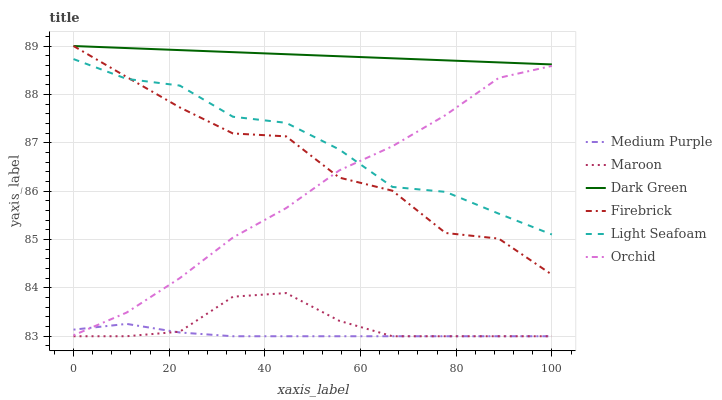Does Medium Purple have the minimum area under the curve?
Answer yes or no. Yes. Does Dark Green have the maximum area under the curve?
Answer yes or no. Yes. Does Maroon have the minimum area under the curve?
Answer yes or no. No. Does Maroon have the maximum area under the curve?
Answer yes or no. No. Is Dark Green the smoothest?
Answer yes or no. Yes. Is Firebrick the roughest?
Answer yes or no. Yes. Is Maroon the smoothest?
Answer yes or no. No. Is Maroon the roughest?
Answer yes or no. No. Does Maroon have the lowest value?
Answer yes or no. Yes. Does Dark Green have the lowest value?
Answer yes or no. No. Does Dark Green have the highest value?
Answer yes or no. Yes. Does Maroon have the highest value?
Answer yes or no. No. Is Medium Purple less than Dark Green?
Answer yes or no. Yes. Is Dark Green greater than Light Seafoam?
Answer yes or no. Yes. Does Medium Purple intersect Orchid?
Answer yes or no. Yes. Is Medium Purple less than Orchid?
Answer yes or no. No. Is Medium Purple greater than Orchid?
Answer yes or no. No. Does Medium Purple intersect Dark Green?
Answer yes or no. No. 